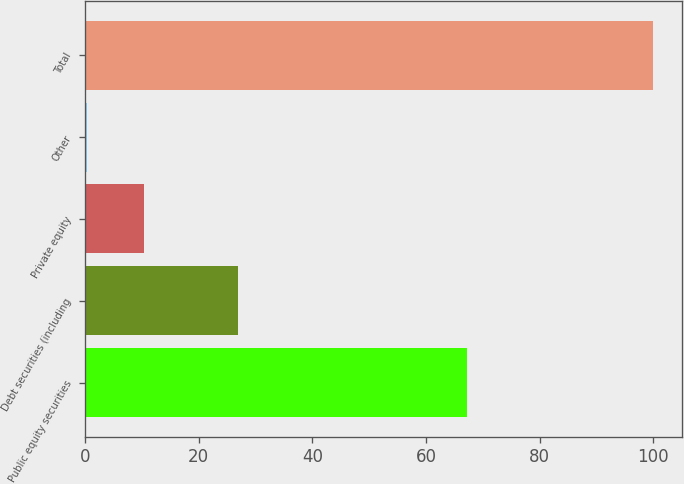<chart> <loc_0><loc_0><loc_500><loc_500><bar_chart><fcel>Public equity securities<fcel>Debt securities (including<fcel>Private equity<fcel>Other<fcel>Total<nl><fcel>67.2<fcel>26.9<fcel>10.27<fcel>0.3<fcel>100<nl></chart> 